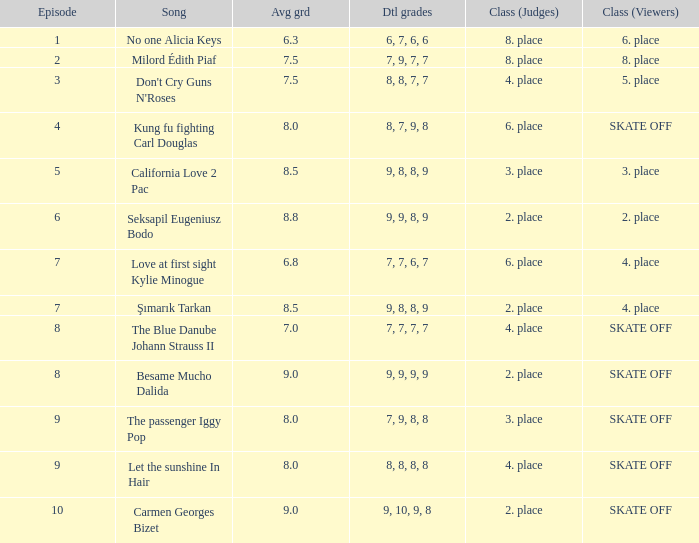Name the classification for 9, 9, 8, 9 2. place. 